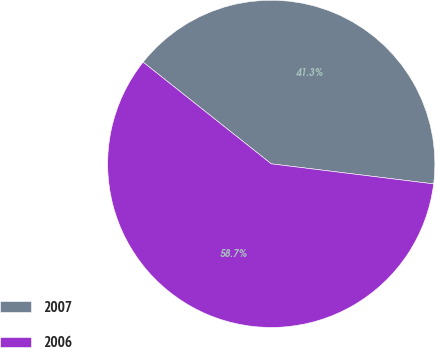Convert chart. <chart><loc_0><loc_0><loc_500><loc_500><pie_chart><fcel>2007<fcel>2006<nl><fcel>41.28%<fcel>58.72%<nl></chart> 